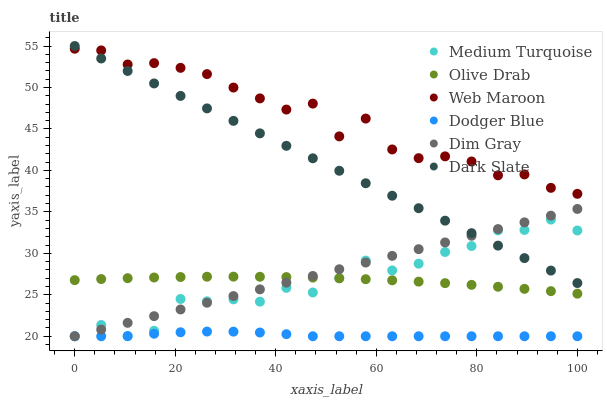Does Dodger Blue have the minimum area under the curve?
Answer yes or no. Yes. Does Web Maroon have the maximum area under the curve?
Answer yes or no. Yes. Does Dark Slate have the minimum area under the curve?
Answer yes or no. No. Does Dark Slate have the maximum area under the curve?
Answer yes or no. No. Is Dim Gray the smoothest?
Answer yes or no. Yes. Is Web Maroon the roughest?
Answer yes or no. Yes. Is Dark Slate the smoothest?
Answer yes or no. No. Is Dark Slate the roughest?
Answer yes or no. No. Does Dim Gray have the lowest value?
Answer yes or no. Yes. Does Dark Slate have the lowest value?
Answer yes or no. No. Does Dark Slate have the highest value?
Answer yes or no. Yes. Does Web Maroon have the highest value?
Answer yes or no. No. Is Dodger Blue less than Web Maroon?
Answer yes or no. Yes. Is Web Maroon greater than Dodger Blue?
Answer yes or no. Yes. Does Medium Turquoise intersect Dim Gray?
Answer yes or no. Yes. Is Medium Turquoise less than Dim Gray?
Answer yes or no. No. Is Medium Turquoise greater than Dim Gray?
Answer yes or no. No. Does Dodger Blue intersect Web Maroon?
Answer yes or no. No. 